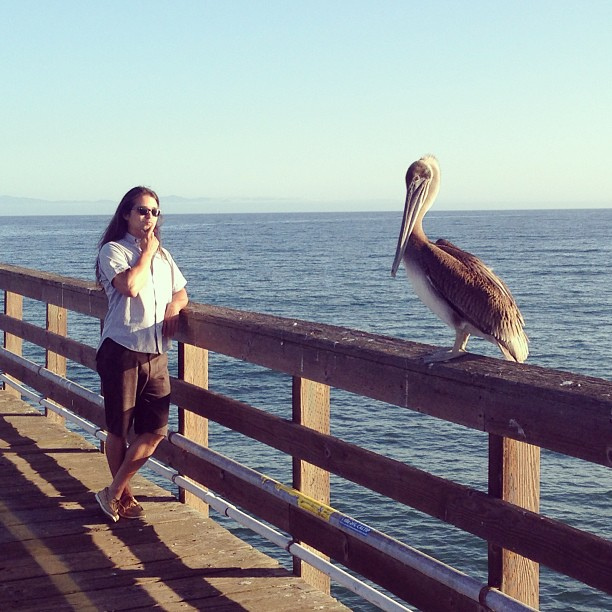<image>Why has the pelican remained on the pier? The reason for the pelican's stay at the pier is unknown. It could be due to various reasons such as looking for food, resting, or being fed. Why has the pelican remained on the pier? I don't know why the pelican has remained on the pier. It can be waiting to be fed, looking for fish, resting, or because it wants to. 